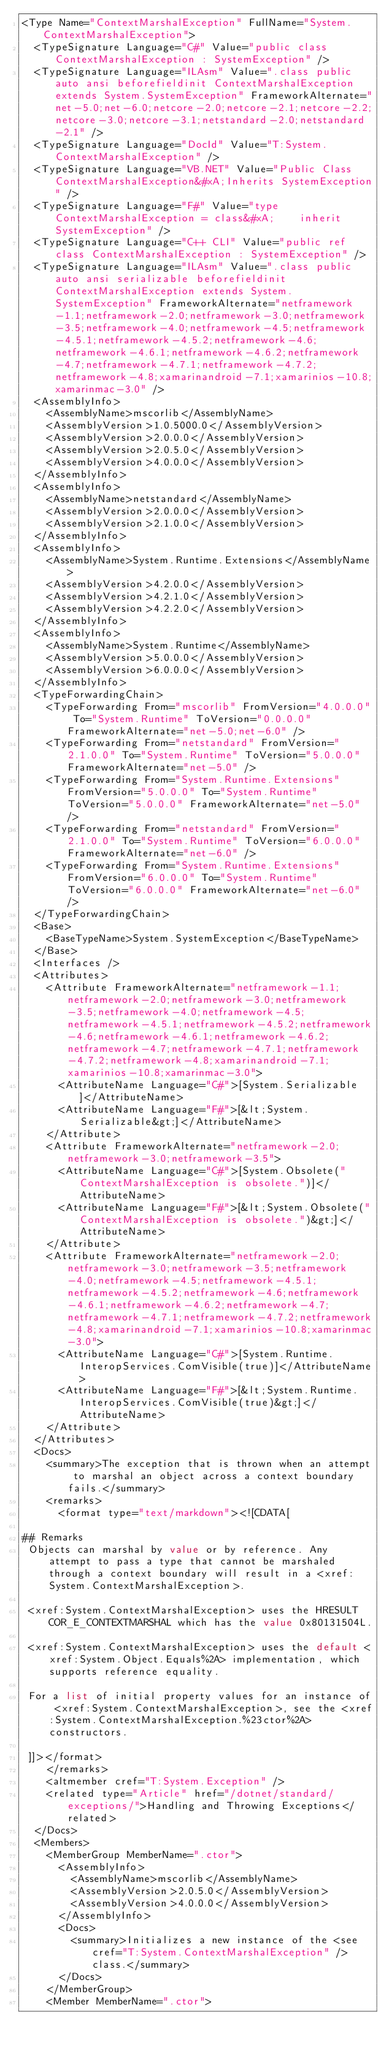<code> <loc_0><loc_0><loc_500><loc_500><_XML_><Type Name="ContextMarshalException" FullName="System.ContextMarshalException">
  <TypeSignature Language="C#" Value="public class ContextMarshalException : SystemException" />
  <TypeSignature Language="ILAsm" Value=".class public auto ansi beforefieldinit ContextMarshalException extends System.SystemException" FrameworkAlternate="net-5.0;net-6.0;netcore-2.0;netcore-2.1;netcore-2.2;netcore-3.0;netcore-3.1;netstandard-2.0;netstandard-2.1" />
  <TypeSignature Language="DocId" Value="T:System.ContextMarshalException" />
  <TypeSignature Language="VB.NET" Value="Public Class ContextMarshalException&#xA;Inherits SystemException" />
  <TypeSignature Language="F#" Value="type ContextMarshalException = class&#xA;    inherit SystemException" />
  <TypeSignature Language="C++ CLI" Value="public ref class ContextMarshalException : SystemException" />
  <TypeSignature Language="ILAsm" Value=".class public auto ansi serializable beforefieldinit ContextMarshalException extends System.SystemException" FrameworkAlternate="netframework-1.1;netframework-2.0;netframework-3.0;netframework-3.5;netframework-4.0;netframework-4.5;netframework-4.5.1;netframework-4.5.2;netframework-4.6;netframework-4.6.1;netframework-4.6.2;netframework-4.7;netframework-4.7.1;netframework-4.7.2;netframework-4.8;xamarinandroid-7.1;xamarinios-10.8;xamarinmac-3.0" />
  <AssemblyInfo>
    <AssemblyName>mscorlib</AssemblyName>
    <AssemblyVersion>1.0.5000.0</AssemblyVersion>
    <AssemblyVersion>2.0.0.0</AssemblyVersion>
    <AssemblyVersion>2.0.5.0</AssemblyVersion>
    <AssemblyVersion>4.0.0.0</AssemblyVersion>
  </AssemblyInfo>
  <AssemblyInfo>
    <AssemblyName>netstandard</AssemblyName>
    <AssemblyVersion>2.0.0.0</AssemblyVersion>
    <AssemblyVersion>2.1.0.0</AssemblyVersion>
  </AssemblyInfo>
  <AssemblyInfo>
    <AssemblyName>System.Runtime.Extensions</AssemblyName>
    <AssemblyVersion>4.2.0.0</AssemblyVersion>
    <AssemblyVersion>4.2.1.0</AssemblyVersion>
    <AssemblyVersion>4.2.2.0</AssemblyVersion>
  </AssemblyInfo>
  <AssemblyInfo>
    <AssemblyName>System.Runtime</AssemblyName>
    <AssemblyVersion>5.0.0.0</AssemblyVersion>
    <AssemblyVersion>6.0.0.0</AssemblyVersion>
  </AssemblyInfo>
  <TypeForwardingChain>
    <TypeForwarding From="mscorlib" FromVersion="4.0.0.0" To="System.Runtime" ToVersion="0.0.0.0" FrameworkAlternate="net-5.0;net-6.0" />
    <TypeForwarding From="netstandard" FromVersion="2.1.0.0" To="System.Runtime" ToVersion="5.0.0.0" FrameworkAlternate="net-5.0" />
    <TypeForwarding From="System.Runtime.Extensions" FromVersion="5.0.0.0" To="System.Runtime" ToVersion="5.0.0.0" FrameworkAlternate="net-5.0" />
    <TypeForwarding From="netstandard" FromVersion="2.1.0.0" To="System.Runtime" ToVersion="6.0.0.0" FrameworkAlternate="net-6.0" />
    <TypeForwarding From="System.Runtime.Extensions" FromVersion="6.0.0.0" To="System.Runtime" ToVersion="6.0.0.0" FrameworkAlternate="net-6.0" />
  </TypeForwardingChain>
  <Base>
    <BaseTypeName>System.SystemException</BaseTypeName>
  </Base>
  <Interfaces />
  <Attributes>
    <Attribute FrameworkAlternate="netframework-1.1;netframework-2.0;netframework-3.0;netframework-3.5;netframework-4.0;netframework-4.5;netframework-4.5.1;netframework-4.5.2;netframework-4.6;netframework-4.6.1;netframework-4.6.2;netframework-4.7;netframework-4.7.1;netframework-4.7.2;netframework-4.8;xamarinandroid-7.1;xamarinios-10.8;xamarinmac-3.0">
      <AttributeName Language="C#">[System.Serializable]</AttributeName>
      <AttributeName Language="F#">[&lt;System.Serializable&gt;]</AttributeName>
    </Attribute>
    <Attribute FrameworkAlternate="netframework-2.0;netframework-3.0;netframework-3.5">
      <AttributeName Language="C#">[System.Obsolete("ContextMarshalException is obsolete.")]</AttributeName>
      <AttributeName Language="F#">[&lt;System.Obsolete("ContextMarshalException is obsolete.")&gt;]</AttributeName>
    </Attribute>
    <Attribute FrameworkAlternate="netframework-2.0;netframework-3.0;netframework-3.5;netframework-4.0;netframework-4.5;netframework-4.5.1;netframework-4.5.2;netframework-4.6;netframework-4.6.1;netframework-4.6.2;netframework-4.7;netframework-4.7.1;netframework-4.7.2;netframework-4.8;xamarinandroid-7.1;xamarinios-10.8;xamarinmac-3.0">
      <AttributeName Language="C#">[System.Runtime.InteropServices.ComVisible(true)]</AttributeName>
      <AttributeName Language="F#">[&lt;System.Runtime.InteropServices.ComVisible(true)&gt;]</AttributeName>
    </Attribute>
  </Attributes>
  <Docs>
    <summary>The exception that is thrown when an attempt to marshal an object across a context boundary fails.</summary>
    <remarks>
      <format type="text/markdown"><![CDATA[  
  
## Remarks  
 Objects can marshal by value or by reference. Any attempt to pass a type that cannot be marshaled through a context boundary will result in a <xref:System.ContextMarshalException>.  
  
 <xref:System.ContextMarshalException> uses the HRESULT COR_E_CONTEXTMARSHAL which has the value 0x80131504L.  
  
 <xref:System.ContextMarshalException> uses the default <xref:System.Object.Equals%2A> implementation, which supports reference equality.  
  
 For a list of initial property values for an instance of <xref:System.ContextMarshalException>, see the <xref:System.ContextMarshalException.%23ctor%2A> constructors.  
  
 ]]></format>
    </remarks>
    <altmember cref="T:System.Exception" />
    <related type="Article" href="/dotnet/standard/exceptions/">Handling and Throwing Exceptions</related>
  </Docs>
  <Members>
    <MemberGroup MemberName=".ctor">
      <AssemblyInfo>
        <AssemblyName>mscorlib</AssemblyName>
        <AssemblyVersion>2.0.5.0</AssemblyVersion>
        <AssemblyVersion>4.0.0.0</AssemblyVersion>
      </AssemblyInfo>
      <Docs>
        <summary>Initializes a new instance of the <see cref="T:System.ContextMarshalException" /> class.</summary>
      </Docs>
    </MemberGroup>
    <Member MemberName=".ctor"></code> 